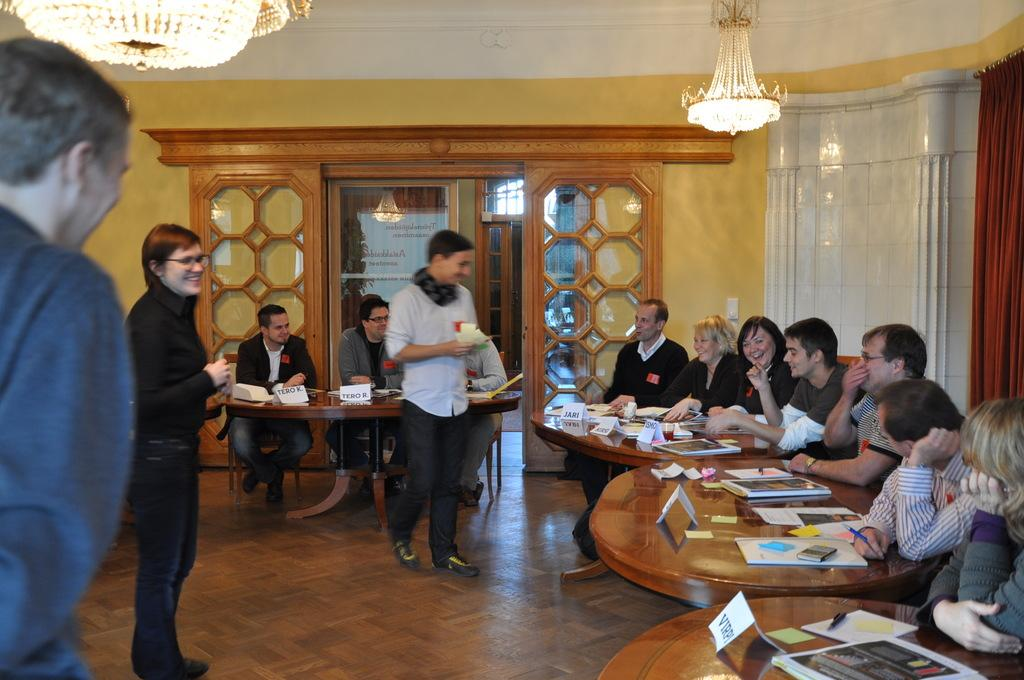What are the people in the image doing? The people in the image are sitting around a table. What objects can be seen on the table? There are books on the table. What is hanging above the table? There is a chandelier hanging above the table. How many chickens are sitting at the table with the people? There are no chickens present in the image; only people are sitting around the table. What type of bone can be seen in the image? There is no bone present in the image. 